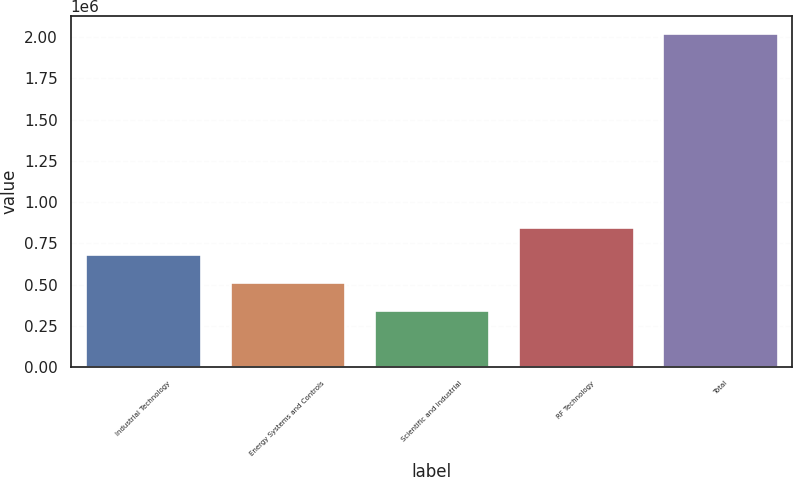<chart> <loc_0><loc_0><loc_500><loc_500><bar_chart><fcel>Industrial Technology<fcel>Energy Systems and Controls<fcel>Scientific and Industrial<fcel>RF Technology<fcel>Total<nl><fcel>684107<fcel>516620<fcel>349132<fcel>851595<fcel>2.02401e+06<nl></chart> 